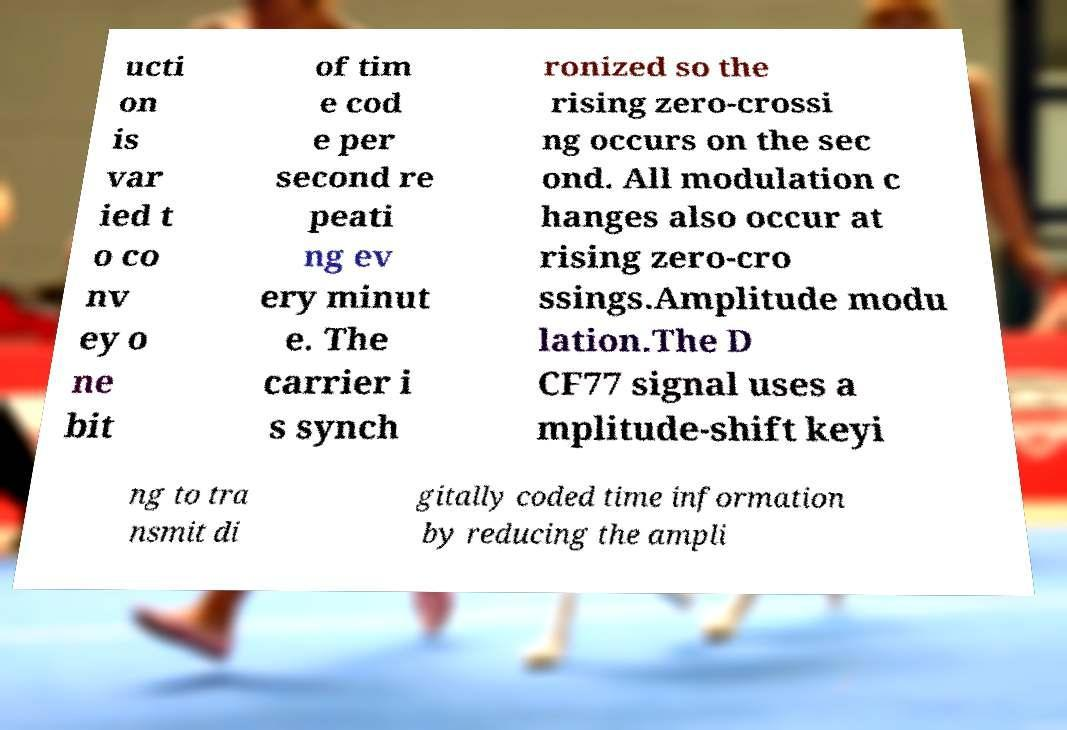Please identify and transcribe the text found in this image. ucti on is var ied t o co nv ey o ne bit of tim e cod e per second re peati ng ev ery minut e. The carrier i s synch ronized so the rising zero-crossi ng occurs on the sec ond. All modulation c hanges also occur at rising zero-cro ssings.Amplitude modu lation.The D CF77 signal uses a mplitude-shift keyi ng to tra nsmit di gitally coded time information by reducing the ampli 